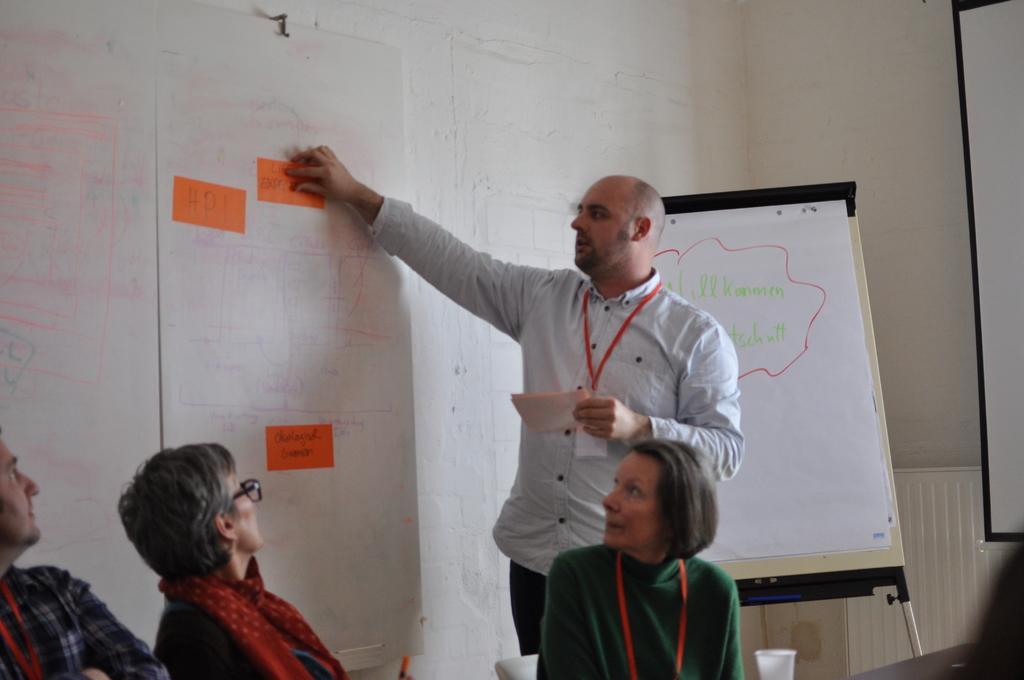Describe this image in one or two sentences. In this image a person is standing and he is holding few papers. He is sticking papers on the board which is attached to the wall. Behind him there is a board on the stand. Bottom of the image there are few persons sitting on the chairs. Right bottom there is a glass. Right side there is a screen. 